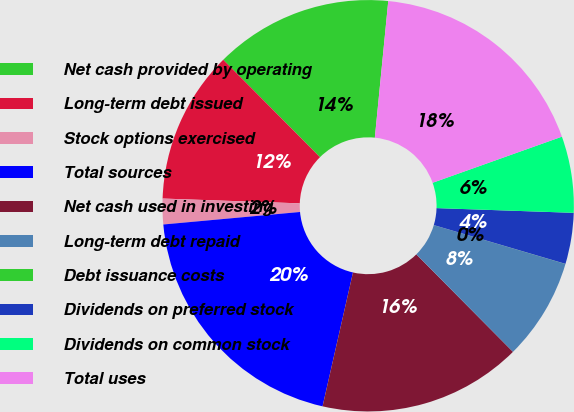Convert chart. <chart><loc_0><loc_0><loc_500><loc_500><pie_chart><fcel>Net cash provided by operating<fcel>Long-term debt issued<fcel>Stock options exercised<fcel>Total sources<fcel>Net cash used in investing<fcel>Long-term debt repaid<fcel>Debt issuance costs<fcel>Dividends on preferred stock<fcel>Dividends on common stock<fcel>Total uses<nl><fcel>14.0%<fcel>12.0%<fcel>2.01%<fcel>19.99%<fcel>15.99%<fcel>8.0%<fcel>0.01%<fcel>4.01%<fcel>6.0%<fcel>17.99%<nl></chart> 